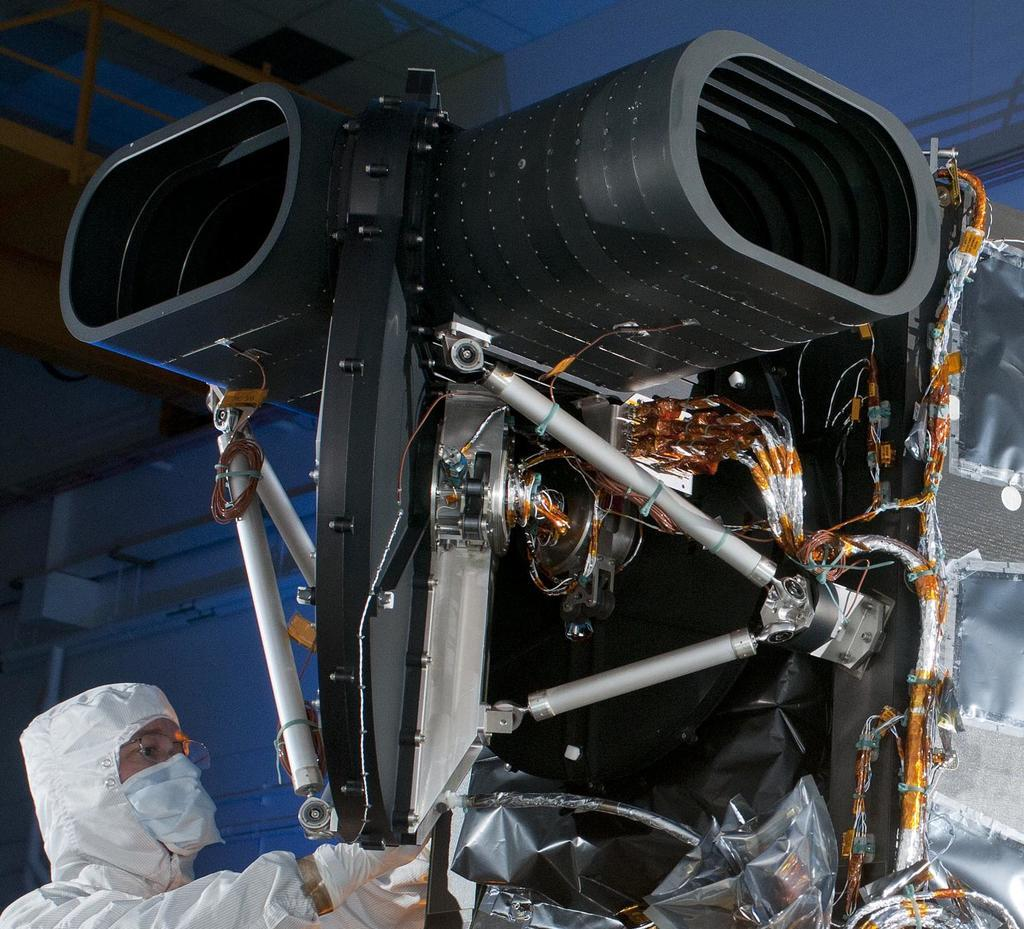What type of instrument is present in the image? There is a mechanical and electrical instrument in the image. Can you describe the person in the image? There is a person standing in the image. What type of news can be seen on the jar in the image? There is no jar present in the image, and therefore no news can be seen on it. Are there any fairies visible in the image? There are no fairies present in the image. 